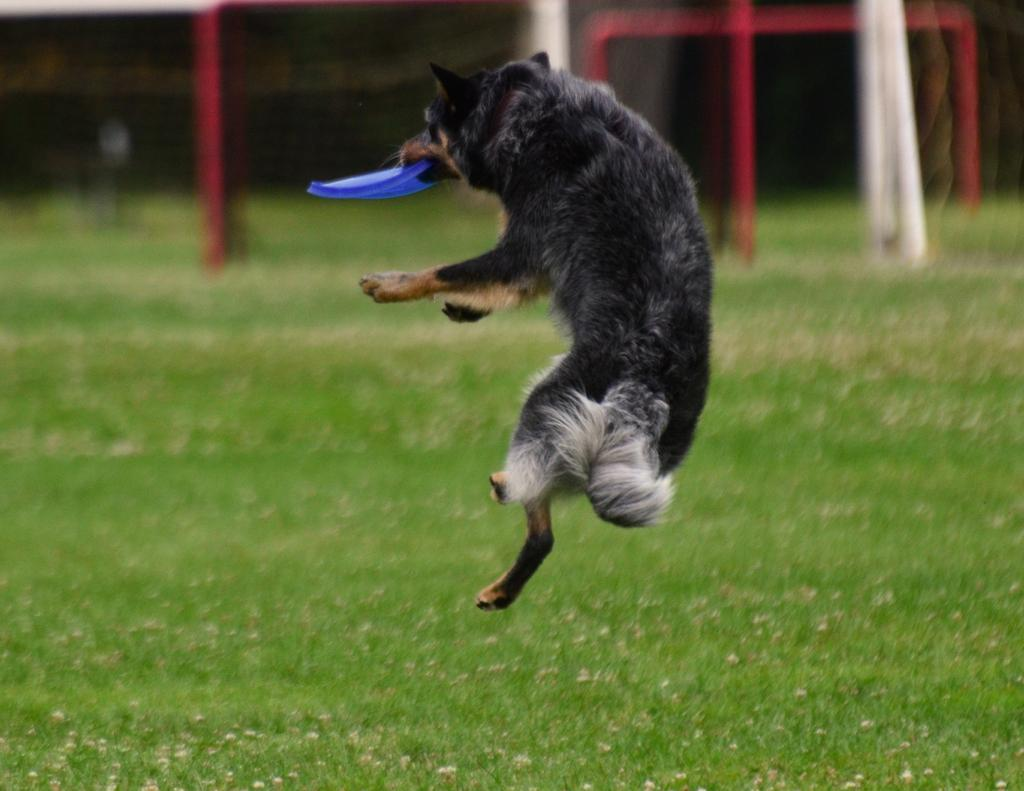What animal is present in the image? There is a dog in the image. What is the dog doing in the image? The dog is holding an object in its mouth and is in the air. What can be seen in the background of the image? There is grass and other objects visible in the background of the image. How many ministers are present in the image? There are no ministers present in the image; it features a dog holding an object in its mouth and in the air. What type of park is visible in the image? There is no park visible in the image; it features a dog holding an object in its mouth and in the air, with grass and other objects in the background. 